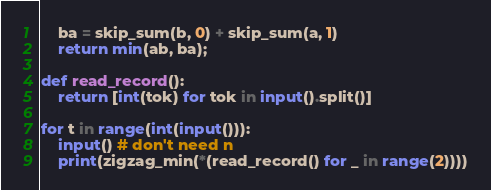Convert code to text. <code><loc_0><loc_0><loc_500><loc_500><_Python_>    ba = skip_sum(b, 0) + skip_sum(a, 1)
    return min(ab, ba);

def read_record():
    return [int(tok) for tok in input().split()]

for t in range(int(input())):
    input() # don't need n
    print(zigzag_min(*(read_record() for _ in range(2))))
</code> 